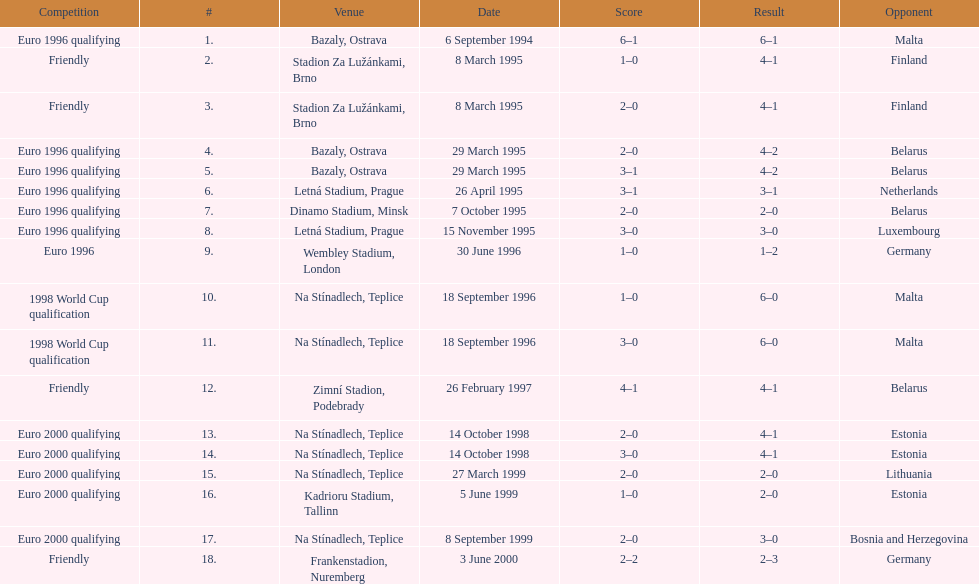What venue is listed above wembley stadium, london? Letná Stadium, Prague. 